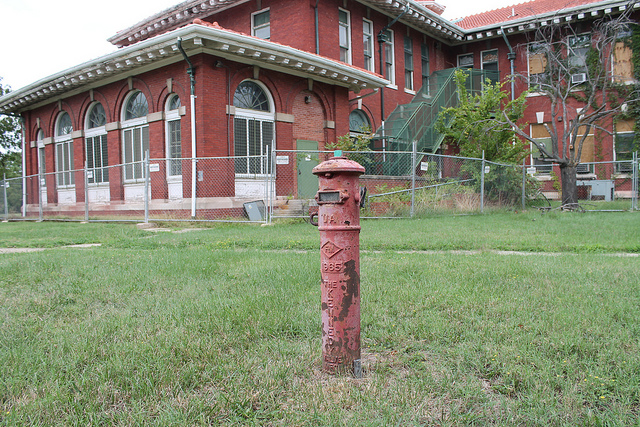Extract all visible text content from this image. 365 